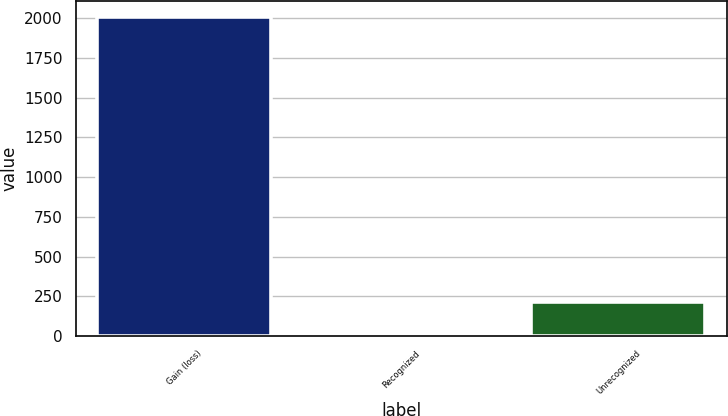Convert chart to OTSL. <chart><loc_0><loc_0><loc_500><loc_500><bar_chart><fcel>Gain (loss)<fcel>Recognized<fcel>Unrecognized<nl><fcel>2008<fcel>12<fcel>211.6<nl></chart> 